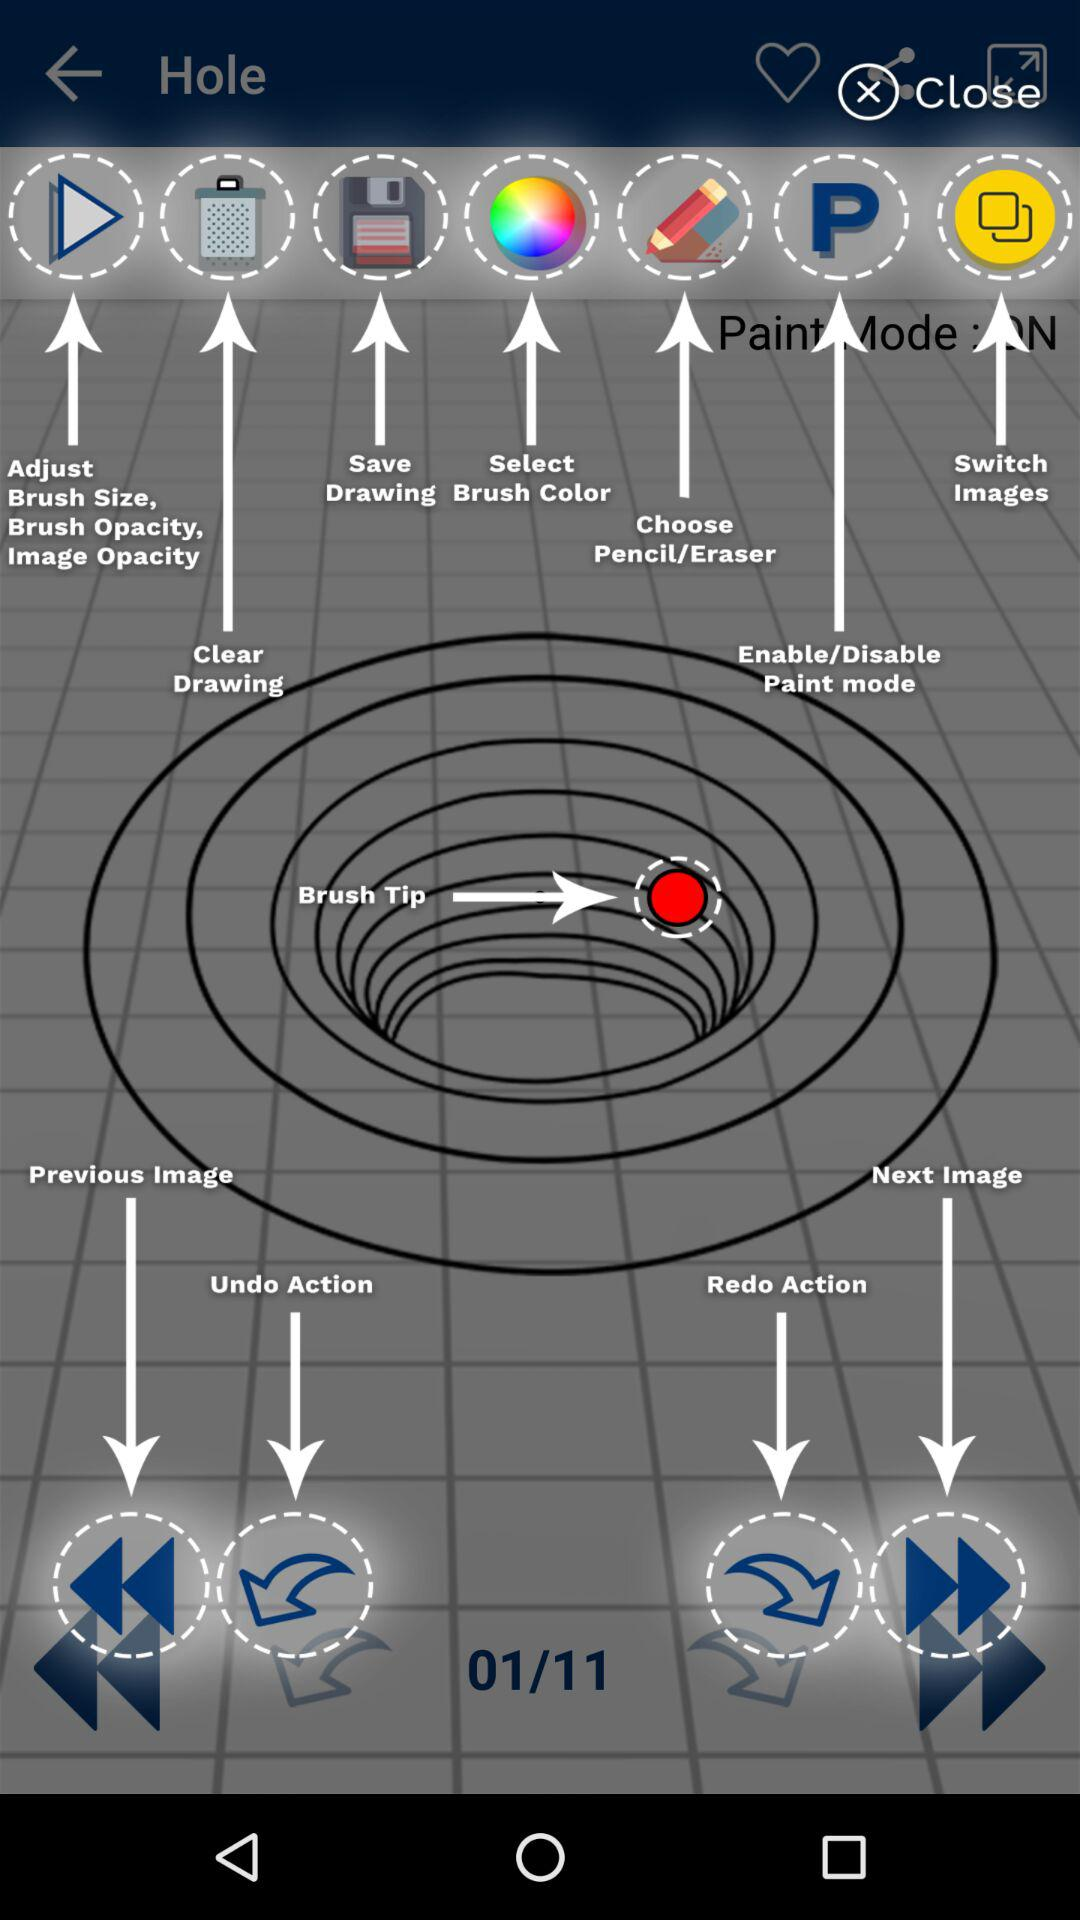Which function is currently active?
When the provided information is insufficient, respond with <no answer>. <no answer> 